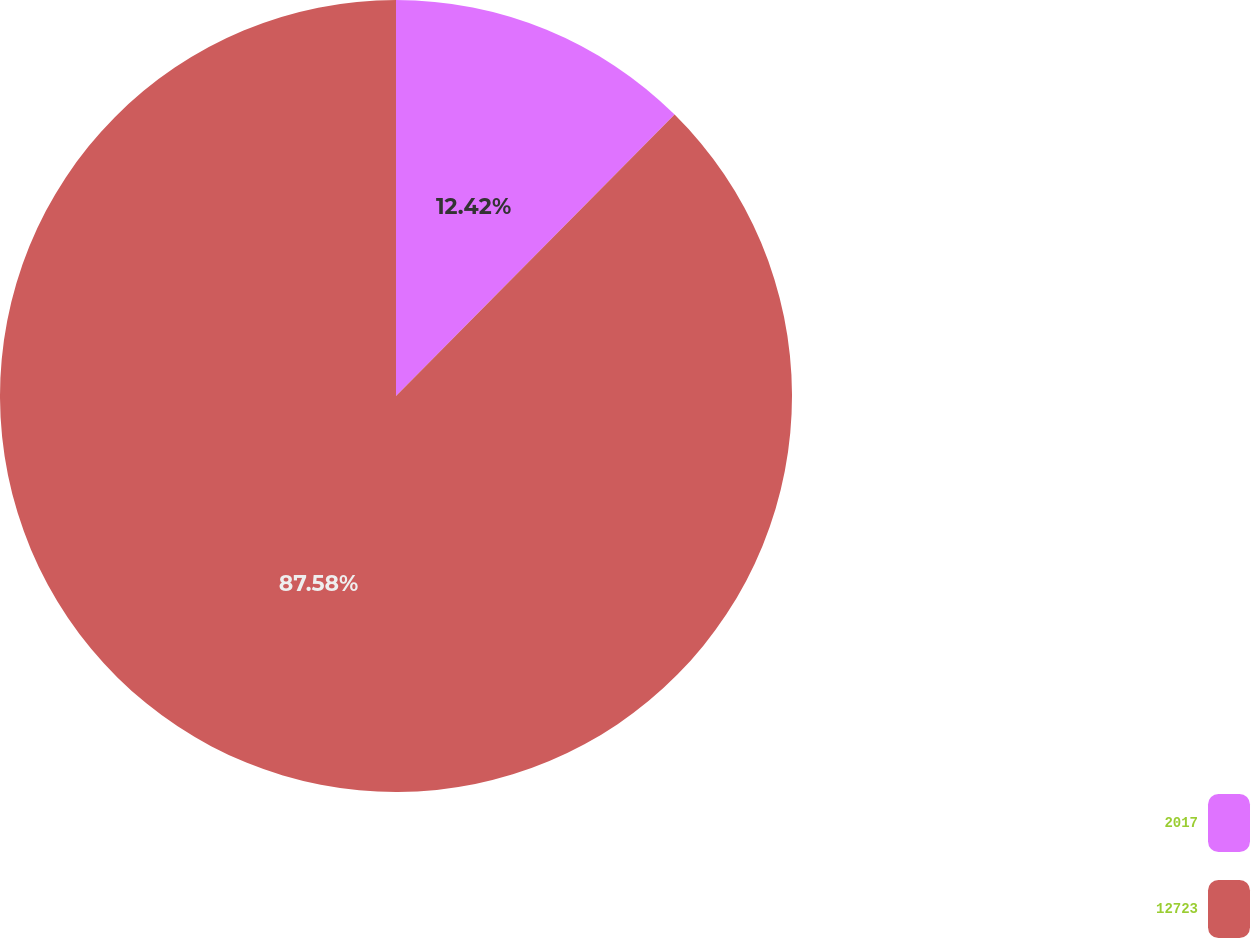<chart> <loc_0><loc_0><loc_500><loc_500><pie_chart><fcel>2017<fcel>12723<nl><fcel>12.42%<fcel>87.58%<nl></chart> 